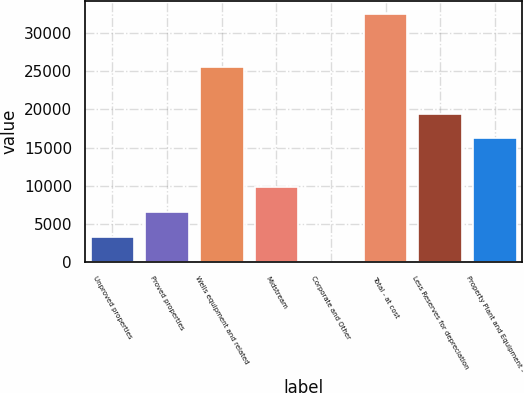<chart> <loc_0><loc_0><loc_500><loc_500><bar_chart><fcel>Unproved properties<fcel>Proved properties<fcel>Wells equipment and related<fcel>Midstream<fcel>Corporate and Other<fcel>Total - at cost<fcel>Less Reserves for depreciation<fcel>Property Plant and Equipment -<nl><fcel>3298.1<fcel>6543.2<fcel>25550<fcel>9788.3<fcel>53<fcel>32504<fcel>19437.1<fcel>16192<nl></chart> 